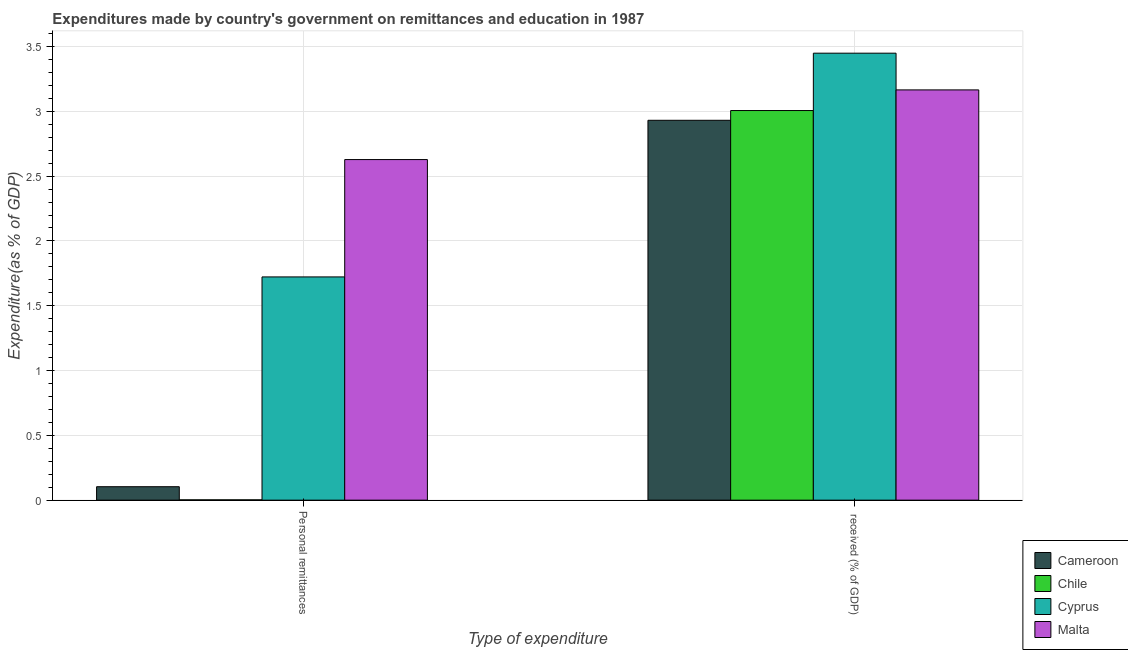How many different coloured bars are there?
Offer a terse response. 4. Are the number of bars on each tick of the X-axis equal?
Your response must be concise. Yes. How many bars are there on the 1st tick from the left?
Keep it short and to the point. 4. What is the label of the 1st group of bars from the left?
Make the answer very short. Personal remittances. What is the expenditure in education in Malta?
Ensure brevity in your answer.  3.17. Across all countries, what is the maximum expenditure in education?
Offer a very short reply. 3.45. Across all countries, what is the minimum expenditure in education?
Provide a succinct answer. 2.93. In which country was the expenditure in education maximum?
Your answer should be compact. Cyprus. In which country was the expenditure in education minimum?
Your answer should be compact. Cameroon. What is the total expenditure in education in the graph?
Offer a very short reply. 12.55. What is the difference between the expenditure in personal remittances in Cyprus and that in Malta?
Provide a short and direct response. -0.91. What is the difference between the expenditure in personal remittances in Malta and the expenditure in education in Cyprus?
Offer a terse response. -0.82. What is the average expenditure in personal remittances per country?
Make the answer very short. 1.11. What is the difference between the expenditure in personal remittances and expenditure in education in Cyprus?
Offer a terse response. -1.73. What is the ratio of the expenditure in education in Cyprus to that in Cameroon?
Give a very brief answer. 1.18. Is the expenditure in education in Cyprus less than that in Cameroon?
Give a very brief answer. No. What does the 1st bar from the left in  received (% of GDP) represents?
Ensure brevity in your answer.  Cameroon. What does the 2nd bar from the right in Personal remittances represents?
Offer a very short reply. Cyprus. How many bars are there?
Your answer should be compact. 8. Are all the bars in the graph horizontal?
Offer a terse response. No. Are the values on the major ticks of Y-axis written in scientific E-notation?
Ensure brevity in your answer.  No. Where does the legend appear in the graph?
Ensure brevity in your answer.  Bottom right. How many legend labels are there?
Provide a short and direct response. 4. How are the legend labels stacked?
Offer a very short reply. Vertical. What is the title of the graph?
Your answer should be compact. Expenditures made by country's government on remittances and education in 1987. Does "Cote d'Ivoire" appear as one of the legend labels in the graph?
Provide a short and direct response. No. What is the label or title of the X-axis?
Provide a short and direct response. Type of expenditure. What is the label or title of the Y-axis?
Give a very brief answer. Expenditure(as % of GDP). What is the Expenditure(as % of GDP) of Cameroon in Personal remittances?
Your answer should be compact. 0.1. What is the Expenditure(as % of GDP) in Chile in Personal remittances?
Ensure brevity in your answer.  0. What is the Expenditure(as % of GDP) in Cyprus in Personal remittances?
Provide a short and direct response. 1.72. What is the Expenditure(as % of GDP) in Malta in Personal remittances?
Keep it short and to the point. 2.63. What is the Expenditure(as % of GDP) in Cameroon in  received (% of GDP)?
Your answer should be very brief. 2.93. What is the Expenditure(as % of GDP) of Chile in  received (% of GDP)?
Keep it short and to the point. 3.01. What is the Expenditure(as % of GDP) of Cyprus in  received (% of GDP)?
Provide a short and direct response. 3.45. What is the Expenditure(as % of GDP) of Malta in  received (% of GDP)?
Make the answer very short. 3.17. Across all Type of expenditure, what is the maximum Expenditure(as % of GDP) in Cameroon?
Your answer should be very brief. 2.93. Across all Type of expenditure, what is the maximum Expenditure(as % of GDP) in Chile?
Make the answer very short. 3.01. Across all Type of expenditure, what is the maximum Expenditure(as % of GDP) of Cyprus?
Ensure brevity in your answer.  3.45. Across all Type of expenditure, what is the maximum Expenditure(as % of GDP) in Malta?
Keep it short and to the point. 3.17. Across all Type of expenditure, what is the minimum Expenditure(as % of GDP) of Cameroon?
Make the answer very short. 0.1. Across all Type of expenditure, what is the minimum Expenditure(as % of GDP) of Chile?
Offer a terse response. 0. Across all Type of expenditure, what is the minimum Expenditure(as % of GDP) in Cyprus?
Offer a very short reply. 1.72. Across all Type of expenditure, what is the minimum Expenditure(as % of GDP) in Malta?
Keep it short and to the point. 2.63. What is the total Expenditure(as % of GDP) in Cameroon in the graph?
Your answer should be compact. 3.03. What is the total Expenditure(as % of GDP) in Chile in the graph?
Make the answer very short. 3.01. What is the total Expenditure(as % of GDP) of Cyprus in the graph?
Your answer should be very brief. 5.17. What is the total Expenditure(as % of GDP) in Malta in the graph?
Keep it short and to the point. 5.79. What is the difference between the Expenditure(as % of GDP) of Cameroon in Personal remittances and that in  received (% of GDP)?
Your answer should be very brief. -2.83. What is the difference between the Expenditure(as % of GDP) in Chile in Personal remittances and that in  received (% of GDP)?
Provide a short and direct response. -3. What is the difference between the Expenditure(as % of GDP) in Cyprus in Personal remittances and that in  received (% of GDP)?
Keep it short and to the point. -1.73. What is the difference between the Expenditure(as % of GDP) of Malta in Personal remittances and that in  received (% of GDP)?
Make the answer very short. -0.54. What is the difference between the Expenditure(as % of GDP) of Cameroon in Personal remittances and the Expenditure(as % of GDP) of Chile in  received (% of GDP)?
Make the answer very short. -2.9. What is the difference between the Expenditure(as % of GDP) in Cameroon in Personal remittances and the Expenditure(as % of GDP) in Cyprus in  received (% of GDP)?
Give a very brief answer. -3.34. What is the difference between the Expenditure(as % of GDP) in Cameroon in Personal remittances and the Expenditure(as % of GDP) in Malta in  received (% of GDP)?
Offer a very short reply. -3.06. What is the difference between the Expenditure(as % of GDP) of Chile in Personal remittances and the Expenditure(as % of GDP) of Cyprus in  received (% of GDP)?
Your answer should be compact. -3.45. What is the difference between the Expenditure(as % of GDP) of Chile in Personal remittances and the Expenditure(as % of GDP) of Malta in  received (% of GDP)?
Provide a short and direct response. -3.16. What is the difference between the Expenditure(as % of GDP) of Cyprus in Personal remittances and the Expenditure(as % of GDP) of Malta in  received (% of GDP)?
Provide a succinct answer. -1.44. What is the average Expenditure(as % of GDP) of Cameroon per Type of expenditure?
Ensure brevity in your answer.  1.52. What is the average Expenditure(as % of GDP) in Chile per Type of expenditure?
Give a very brief answer. 1.5. What is the average Expenditure(as % of GDP) in Cyprus per Type of expenditure?
Provide a succinct answer. 2.59. What is the average Expenditure(as % of GDP) in Malta per Type of expenditure?
Your answer should be compact. 2.9. What is the difference between the Expenditure(as % of GDP) in Cameroon and Expenditure(as % of GDP) in Chile in Personal remittances?
Keep it short and to the point. 0.1. What is the difference between the Expenditure(as % of GDP) in Cameroon and Expenditure(as % of GDP) in Cyprus in Personal remittances?
Your answer should be compact. -1.62. What is the difference between the Expenditure(as % of GDP) of Cameroon and Expenditure(as % of GDP) of Malta in Personal remittances?
Keep it short and to the point. -2.52. What is the difference between the Expenditure(as % of GDP) of Chile and Expenditure(as % of GDP) of Cyprus in Personal remittances?
Provide a short and direct response. -1.72. What is the difference between the Expenditure(as % of GDP) in Chile and Expenditure(as % of GDP) in Malta in Personal remittances?
Your answer should be very brief. -2.63. What is the difference between the Expenditure(as % of GDP) of Cyprus and Expenditure(as % of GDP) of Malta in Personal remittances?
Provide a succinct answer. -0.91. What is the difference between the Expenditure(as % of GDP) in Cameroon and Expenditure(as % of GDP) in Chile in  received (% of GDP)?
Your answer should be compact. -0.08. What is the difference between the Expenditure(as % of GDP) of Cameroon and Expenditure(as % of GDP) of Cyprus in  received (% of GDP)?
Make the answer very short. -0.52. What is the difference between the Expenditure(as % of GDP) of Cameroon and Expenditure(as % of GDP) of Malta in  received (% of GDP)?
Provide a succinct answer. -0.23. What is the difference between the Expenditure(as % of GDP) in Chile and Expenditure(as % of GDP) in Cyprus in  received (% of GDP)?
Your answer should be compact. -0.44. What is the difference between the Expenditure(as % of GDP) in Chile and Expenditure(as % of GDP) in Malta in  received (% of GDP)?
Ensure brevity in your answer.  -0.16. What is the difference between the Expenditure(as % of GDP) of Cyprus and Expenditure(as % of GDP) of Malta in  received (% of GDP)?
Keep it short and to the point. 0.28. What is the ratio of the Expenditure(as % of GDP) in Cameroon in Personal remittances to that in  received (% of GDP)?
Provide a short and direct response. 0.04. What is the ratio of the Expenditure(as % of GDP) of Chile in Personal remittances to that in  received (% of GDP)?
Offer a terse response. 0. What is the ratio of the Expenditure(as % of GDP) of Cyprus in Personal remittances to that in  received (% of GDP)?
Offer a very short reply. 0.5. What is the ratio of the Expenditure(as % of GDP) in Malta in Personal remittances to that in  received (% of GDP)?
Offer a very short reply. 0.83. What is the difference between the highest and the second highest Expenditure(as % of GDP) in Cameroon?
Offer a very short reply. 2.83. What is the difference between the highest and the second highest Expenditure(as % of GDP) in Chile?
Offer a terse response. 3. What is the difference between the highest and the second highest Expenditure(as % of GDP) of Cyprus?
Offer a terse response. 1.73. What is the difference between the highest and the second highest Expenditure(as % of GDP) of Malta?
Keep it short and to the point. 0.54. What is the difference between the highest and the lowest Expenditure(as % of GDP) in Cameroon?
Give a very brief answer. 2.83. What is the difference between the highest and the lowest Expenditure(as % of GDP) of Chile?
Keep it short and to the point. 3. What is the difference between the highest and the lowest Expenditure(as % of GDP) in Cyprus?
Ensure brevity in your answer.  1.73. What is the difference between the highest and the lowest Expenditure(as % of GDP) of Malta?
Keep it short and to the point. 0.54. 